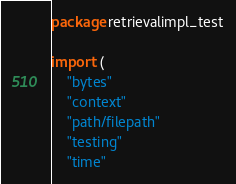Convert code to text. <code><loc_0><loc_0><loc_500><loc_500><_Go_>package retrievalimpl_test

import (
	"bytes"
	"context"
	"path/filepath"
	"testing"
	"time"
</code> 